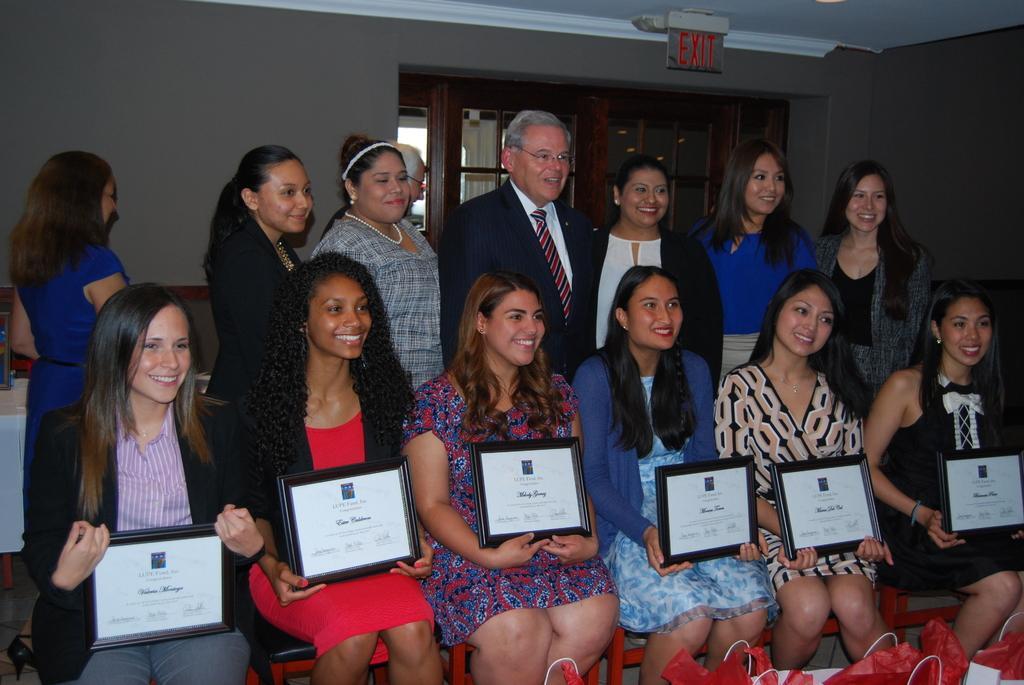How would you summarize this image in a sentence or two? In this image there are people sitting and holding objects, there are persons standing and smiling, there is a wall, there is an exit board attached to the roof, there are windows, there are bags truncated towards the right of the image, there are objects truncated towards the left of the image. 